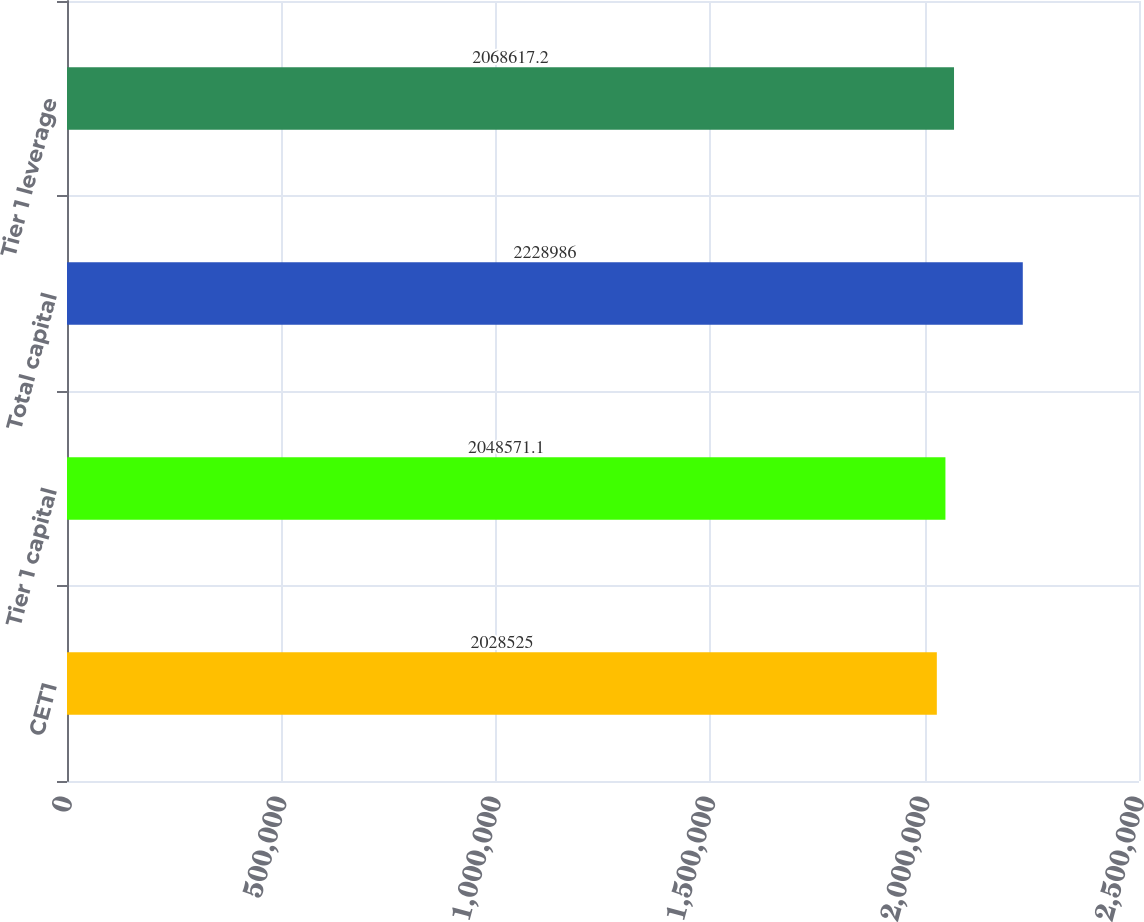Convert chart. <chart><loc_0><loc_0><loc_500><loc_500><bar_chart><fcel>CET1<fcel>Tier 1 capital<fcel>Total capital<fcel>Tier 1 leverage<nl><fcel>2.02852e+06<fcel>2.04857e+06<fcel>2.22899e+06<fcel>2.06862e+06<nl></chart> 